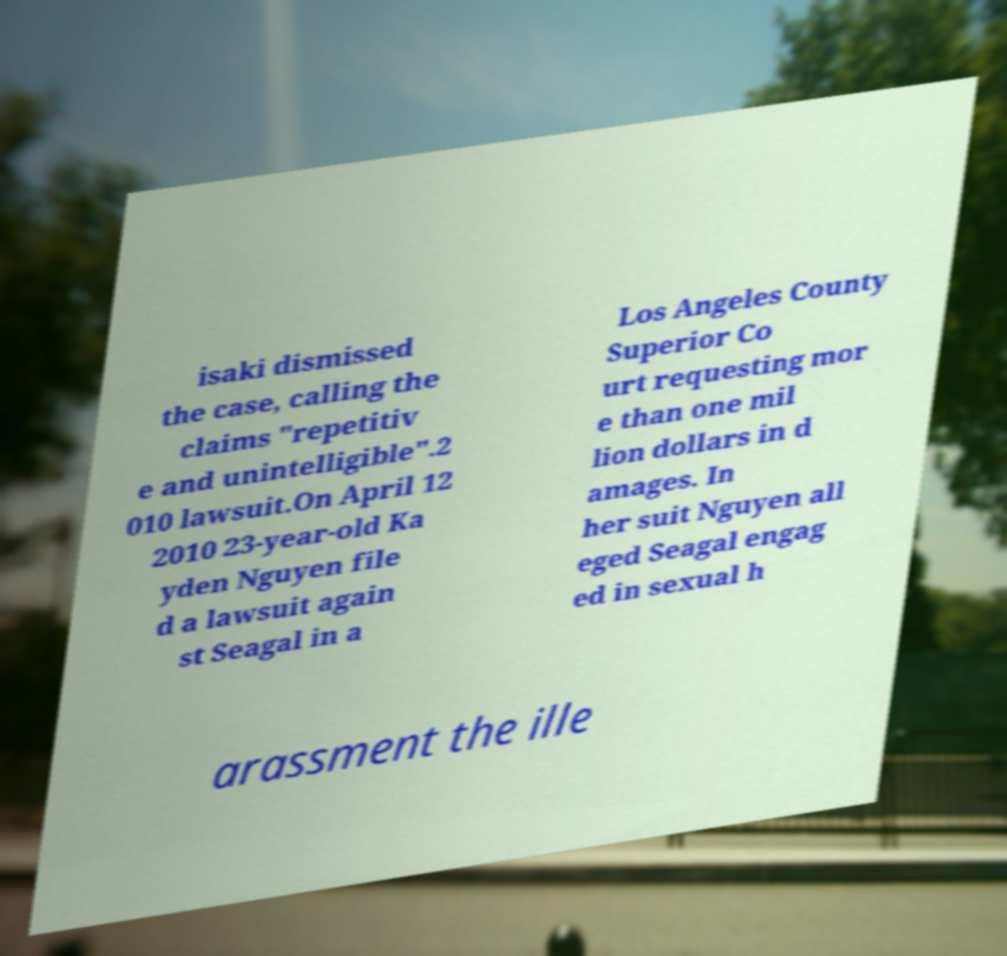There's text embedded in this image that I need extracted. Can you transcribe it verbatim? isaki dismissed the case, calling the claims "repetitiv e and unintelligible".2 010 lawsuit.On April 12 2010 23-year-old Ka yden Nguyen file d a lawsuit again st Seagal in a Los Angeles County Superior Co urt requesting mor e than one mil lion dollars in d amages. In her suit Nguyen all eged Seagal engag ed in sexual h arassment the ille 